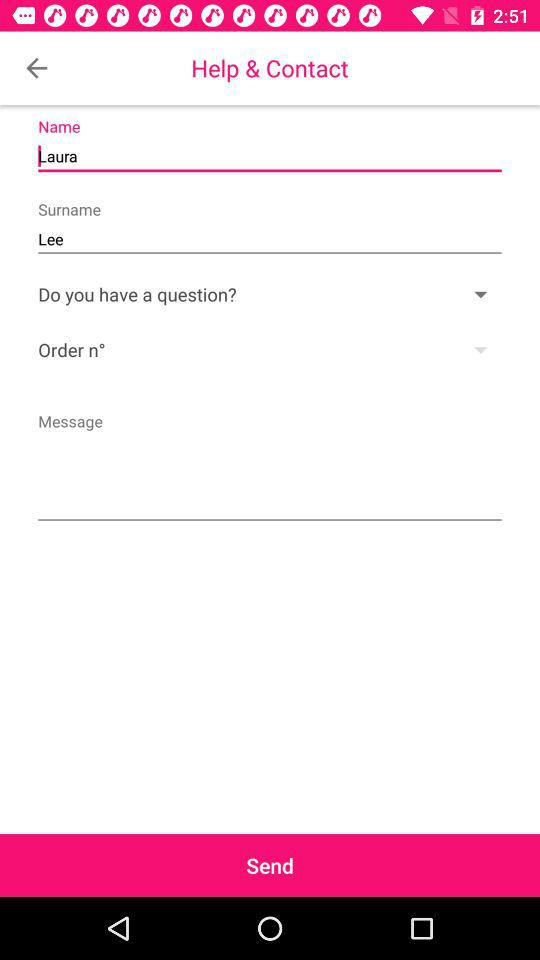What is the surname of the user? The surname of the user is Lee. 